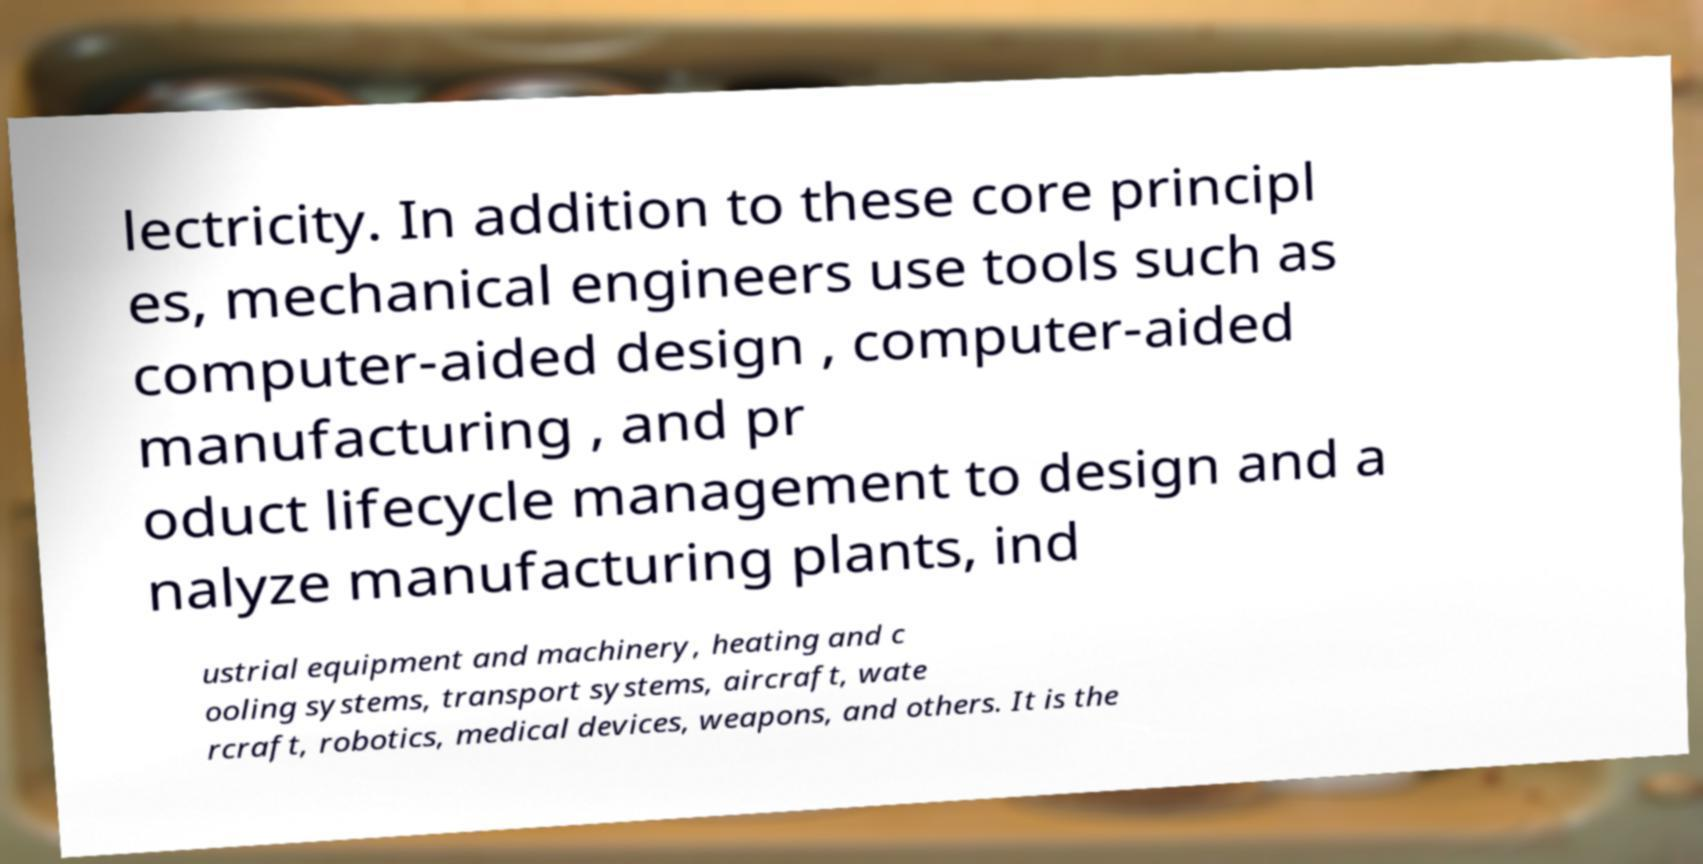Please read and relay the text visible in this image. What does it say? lectricity. In addition to these core principl es, mechanical engineers use tools such as computer-aided design , computer-aided manufacturing , and pr oduct lifecycle management to design and a nalyze manufacturing plants, ind ustrial equipment and machinery, heating and c ooling systems, transport systems, aircraft, wate rcraft, robotics, medical devices, weapons, and others. It is the 